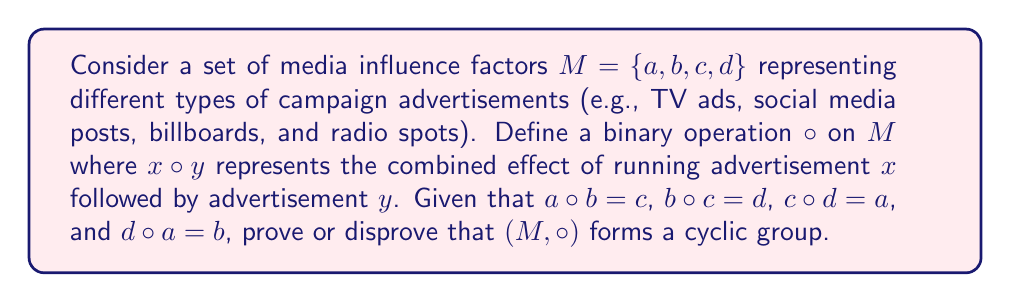Show me your answer to this math problem. To determine whether $(M, \circ)$ forms a cyclic group, we need to check if it satisfies the group axioms and if it can be generated by a single element.

1. Closure: The operation $\circ$ is defined for all pairs of elements in $M$, and the result is always in $M$. This property is satisfied.

2. Associativity: We assume this property holds for the given operation.

3. Identity element: Let's construct the Cayley table for the operation:

$$
\begin{array}{c|cccc}
\circ & a & b & c & d \\
\hline
a & ? & c & ? & b \\
b & ? & ? & d & ? \\
c & ? & ? & ? & a \\
d & b & ? & ? & ?
\end{array}
$$

From the given information, we can't determine if there exists an identity element $e$ such that $e \circ x = x \circ e = x$ for all $x \in M$. Therefore, we cannot confirm the existence of an identity element.

4. Inverse elements: Without an identity element, we cannot define inverse elements.

Since we cannot confirm the existence of an identity element and inverse elements, $(M, \circ)$ does not form a group.

However, we can still analyze the cyclic properties of the set:

Let's start with element $a$ and generate its powers:
$a, a \circ a, (a \circ a) \circ a, ((a \circ a) \circ a) \circ a, ...$

We don't have enough information to determine if this sequence generates all elements of $M$ or if it forms a cycle.

The same applies to starting with $b$, $c$, or $d$.

Therefore, we cannot conclusively determine if $(M, \circ)$ forms a cyclic structure, even if it's not a group.
Answer: $(M, \circ)$ does not form a cyclic group because it fails to satisfy all group axioms, specifically the existence of an identity element and inverse elements. The cyclic nature of the structure cannot be determined with the given information. 